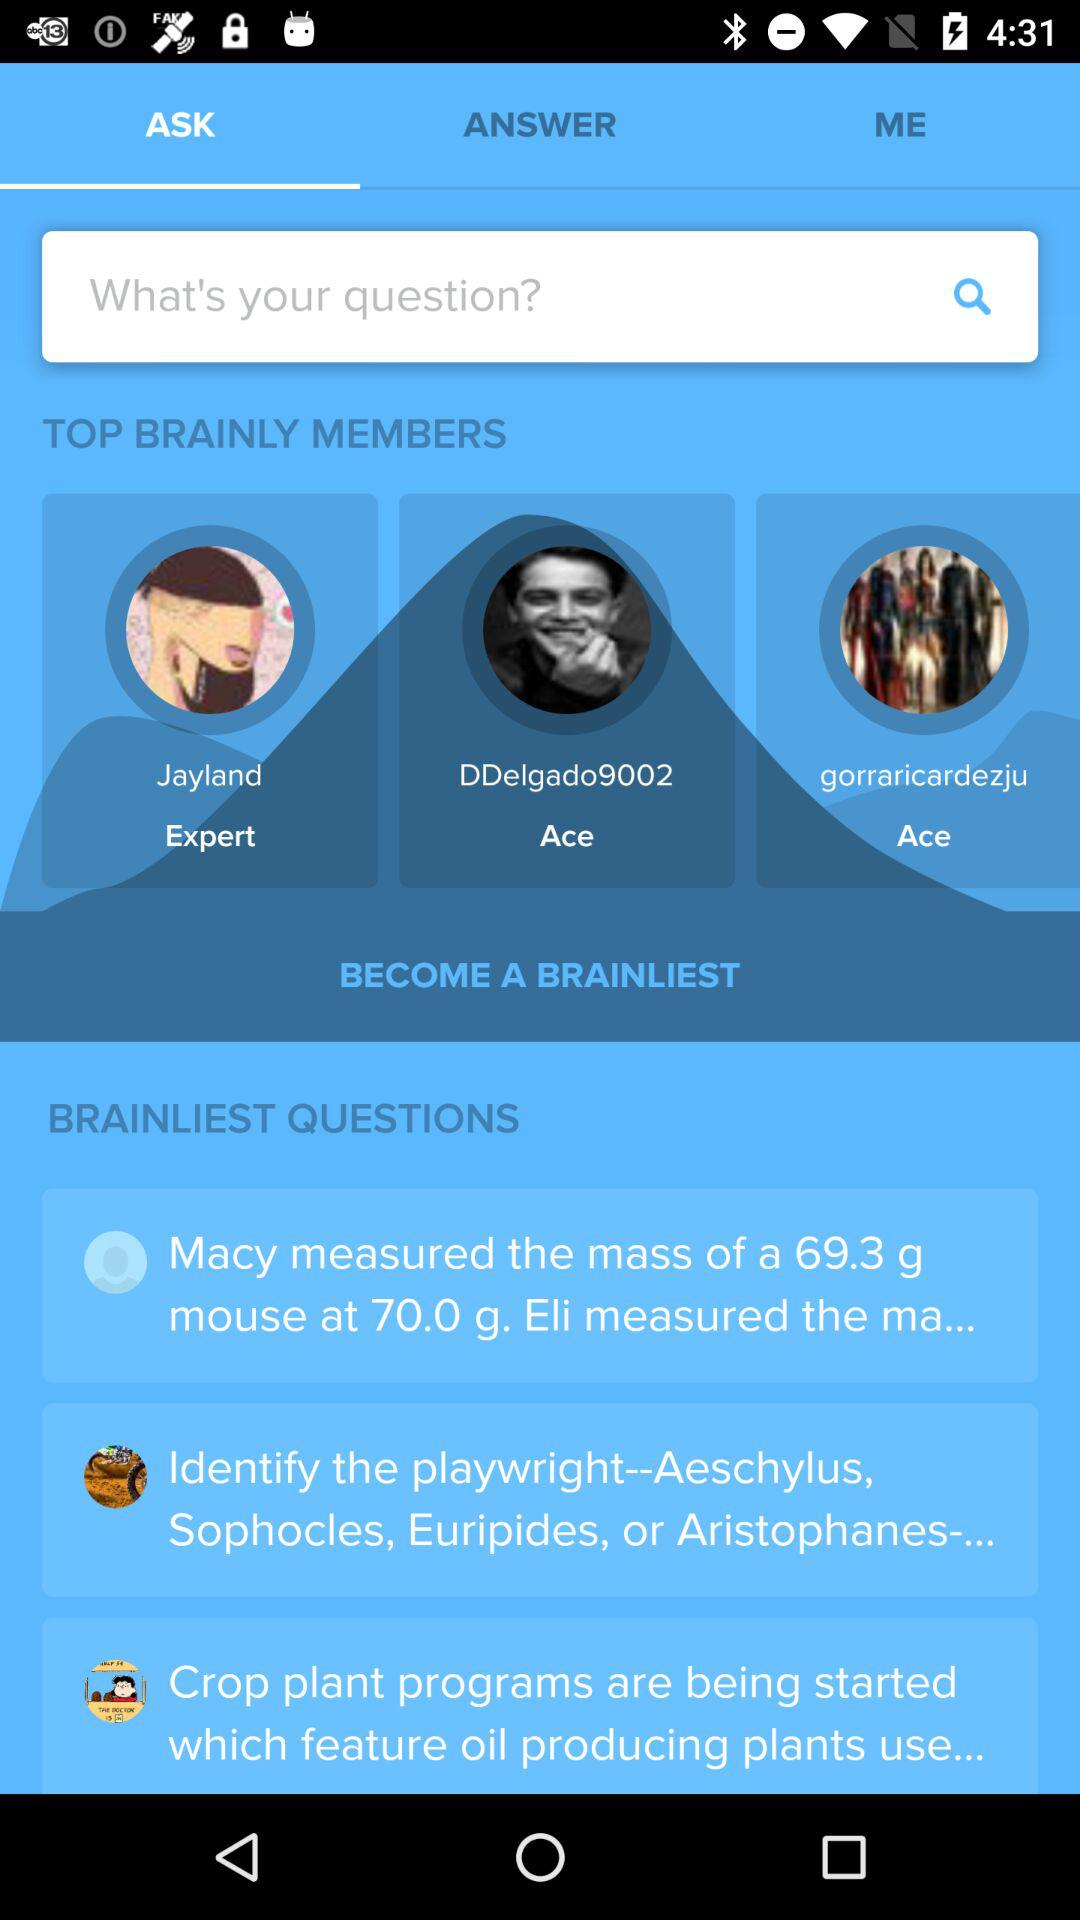Which tab is selected? The selected tab is "ASK". 